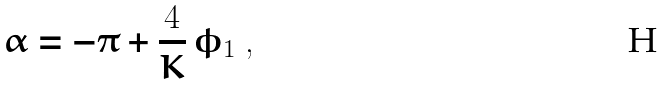Convert formula to latex. <formula><loc_0><loc_0><loc_500><loc_500>\alpha = - \pi + \frac { 4 } { K } \, \phi _ { 1 } \ ,</formula> 